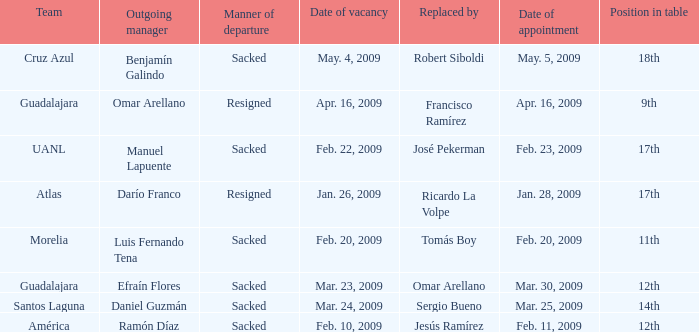What is Position in Table, when Team is "Morelia"? 11th. 